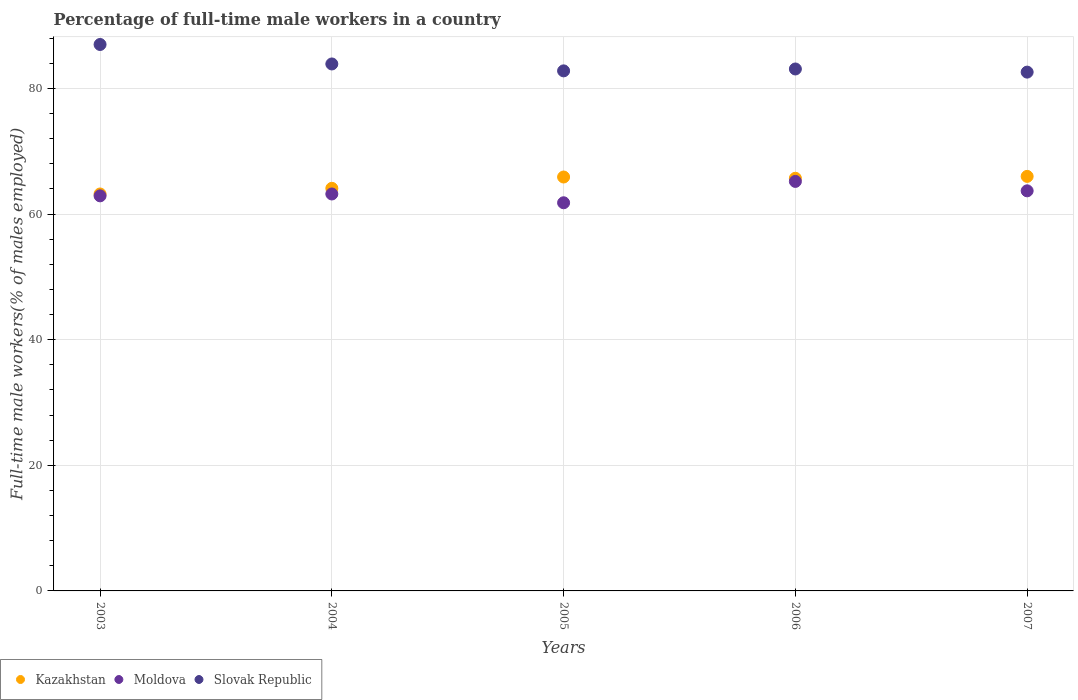How many different coloured dotlines are there?
Your response must be concise. 3. What is the percentage of full-time male workers in Slovak Republic in 2004?
Offer a very short reply. 83.9. Across all years, what is the maximum percentage of full-time male workers in Kazakhstan?
Offer a very short reply. 66. Across all years, what is the minimum percentage of full-time male workers in Moldova?
Ensure brevity in your answer.  61.8. What is the total percentage of full-time male workers in Moldova in the graph?
Keep it short and to the point. 316.8. What is the difference between the percentage of full-time male workers in Slovak Republic in 2004 and that in 2006?
Your answer should be very brief. 0.8. What is the difference between the percentage of full-time male workers in Slovak Republic in 2006 and the percentage of full-time male workers in Kazakhstan in 2003?
Keep it short and to the point. 19.9. What is the average percentage of full-time male workers in Kazakhstan per year?
Ensure brevity in your answer.  64.98. In the year 2003, what is the difference between the percentage of full-time male workers in Slovak Republic and percentage of full-time male workers in Kazakhstan?
Ensure brevity in your answer.  23.8. What is the ratio of the percentage of full-time male workers in Kazakhstan in 2004 to that in 2007?
Offer a terse response. 0.97. Is the percentage of full-time male workers in Moldova in 2003 less than that in 2006?
Make the answer very short. Yes. Is the difference between the percentage of full-time male workers in Slovak Republic in 2006 and 2007 greater than the difference between the percentage of full-time male workers in Kazakhstan in 2006 and 2007?
Make the answer very short. Yes. What is the difference between the highest and the second highest percentage of full-time male workers in Moldova?
Provide a short and direct response. 1.5. What is the difference between the highest and the lowest percentage of full-time male workers in Moldova?
Your response must be concise. 3.4. Is the sum of the percentage of full-time male workers in Kazakhstan in 2005 and 2007 greater than the maximum percentage of full-time male workers in Slovak Republic across all years?
Keep it short and to the point. Yes. Does the percentage of full-time male workers in Slovak Republic monotonically increase over the years?
Make the answer very short. No. Is the percentage of full-time male workers in Slovak Republic strictly greater than the percentage of full-time male workers in Kazakhstan over the years?
Provide a short and direct response. Yes. Is the percentage of full-time male workers in Moldova strictly less than the percentage of full-time male workers in Kazakhstan over the years?
Give a very brief answer. Yes. How many dotlines are there?
Make the answer very short. 3. How many years are there in the graph?
Make the answer very short. 5. Does the graph contain grids?
Provide a succinct answer. Yes. How many legend labels are there?
Offer a very short reply. 3. How are the legend labels stacked?
Provide a succinct answer. Horizontal. What is the title of the graph?
Ensure brevity in your answer.  Percentage of full-time male workers in a country. Does "Vanuatu" appear as one of the legend labels in the graph?
Offer a terse response. No. What is the label or title of the X-axis?
Provide a succinct answer. Years. What is the label or title of the Y-axis?
Make the answer very short. Full-time male workers(% of males employed). What is the Full-time male workers(% of males employed) of Kazakhstan in 2003?
Offer a terse response. 63.2. What is the Full-time male workers(% of males employed) in Moldova in 2003?
Offer a very short reply. 62.9. What is the Full-time male workers(% of males employed) of Kazakhstan in 2004?
Keep it short and to the point. 64.1. What is the Full-time male workers(% of males employed) of Moldova in 2004?
Your answer should be very brief. 63.2. What is the Full-time male workers(% of males employed) of Slovak Republic in 2004?
Ensure brevity in your answer.  83.9. What is the Full-time male workers(% of males employed) in Kazakhstan in 2005?
Keep it short and to the point. 65.9. What is the Full-time male workers(% of males employed) of Moldova in 2005?
Provide a short and direct response. 61.8. What is the Full-time male workers(% of males employed) in Slovak Republic in 2005?
Provide a short and direct response. 82.8. What is the Full-time male workers(% of males employed) of Kazakhstan in 2006?
Provide a short and direct response. 65.7. What is the Full-time male workers(% of males employed) of Moldova in 2006?
Give a very brief answer. 65.2. What is the Full-time male workers(% of males employed) of Slovak Republic in 2006?
Make the answer very short. 83.1. What is the Full-time male workers(% of males employed) of Kazakhstan in 2007?
Make the answer very short. 66. What is the Full-time male workers(% of males employed) of Moldova in 2007?
Make the answer very short. 63.7. What is the Full-time male workers(% of males employed) in Slovak Republic in 2007?
Offer a very short reply. 82.6. Across all years, what is the maximum Full-time male workers(% of males employed) of Moldova?
Ensure brevity in your answer.  65.2. Across all years, what is the maximum Full-time male workers(% of males employed) in Slovak Republic?
Offer a very short reply. 87. Across all years, what is the minimum Full-time male workers(% of males employed) of Kazakhstan?
Provide a succinct answer. 63.2. Across all years, what is the minimum Full-time male workers(% of males employed) in Moldova?
Your answer should be very brief. 61.8. Across all years, what is the minimum Full-time male workers(% of males employed) in Slovak Republic?
Ensure brevity in your answer.  82.6. What is the total Full-time male workers(% of males employed) of Kazakhstan in the graph?
Your answer should be compact. 324.9. What is the total Full-time male workers(% of males employed) in Moldova in the graph?
Ensure brevity in your answer.  316.8. What is the total Full-time male workers(% of males employed) in Slovak Republic in the graph?
Give a very brief answer. 419.4. What is the difference between the Full-time male workers(% of males employed) of Kazakhstan in 2003 and that in 2004?
Your answer should be very brief. -0.9. What is the difference between the Full-time male workers(% of males employed) of Moldova in 2003 and that in 2004?
Give a very brief answer. -0.3. What is the difference between the Full-time male workers(% of males employed) in Moldova in 2003 and that in 2005?
Provide a succinct answer. 1.1. What is the difference between the Full-time male workers(% of males employed) of Slovak Republic in 2003 and that in 2005?
Offer a very short reply. 4.2. What is the difference between the Full-time male workers(% of males employed) in Kazakhstan in 2003 and that in 2006?
Keep it short and to the point. -2.5. What is the difference between the Full-time male workers(% of males employed) in Slovak Republic in 2004 and that in 2005?
Provide a short and direct response. 1.1. What is the difference between the Full-time male workers(% of males employed) in Kazakhstan in 2004 and that in 2006?
Provide a short and direct response. -1.6. What is the difference between the Full-time male workers(% of males employed) of Slovak Republic in 2004 and that in 2006?
Offer a very short reply. 0.8. What is the difference between the Full-time male workers(% of males employed) of Kazakhstan in 2004 and that in 2007?
Make the answer very short. -1.9. What is the difference between the Full-time male workers(% of males employed) in Moldova in 2004 and that in 2007?
Keep it short and to the point. -0.5. What is the difference between the Full-time male workers(% of males employed) in Slovak Republic in 2004 and that in 2007?
Offer a terse response. 1.3. What is the difference between the Full-time male workers(% of males employed) in Kazakhstan in 2005 and that in 2006?
Your response must be concise. 0.2. What is the difference between the Full-time male workers(% of males employed) of Kazakhstan in 2005 and that in 2007?
Provide a succinct answer. -0.1. What is the difference between the Full-time male workers(% of males employed) of Slovak Republic in 2006 and that in 2007?
Make the answer very short. 0.5. What is the difference between the Full-time male workers(% of males employed) of Kazakhstan in 2003 and the Full-time male workers(% of males employed) of Slovak Republic in 2004?
Make the answer very short. -20.7. What is the difference between the Full-time male workers(% of males employed) in Kazakhstan in 2003 and the Full-time male workers(% of males employed) in Slovak Republic in 2005?
Offer a terse response. -19.6. What is the difference between the Full-time male workers(% of males employed) in Moldova in 2003 and the Full-time male workers(% of males employed) in Slovak Republic in 2005?
Your answer should be very brief. -19.9. What is the difference between the Full-time male workers(% of males employed) in Kazakhstan in 2003 and the Full-time male workers(% of males employed) in Moldova in 2006?
Your answer should be compact. -2. What is the difference between the Full-time male workers(% of males employed) of Kazakhstan in 2003 and the Full-time male workers(% of males employed) of Slovak Republic in 2006?
Provide a succinct answer. -19.9. What is the difference between the Full-time male workers(% of males employed) in Moldova in 2003 and the Full-time male workers(% of males employed) in Slovak Republic in 2006?
Keep it short and to the point. -20.2. What is the difference between the Full-time male workers(% of males employed) in Kazakhstan in 2003 and the Full-time male workers(% of males employed) in Slovak Republic in 2007?
Provide a succinct answer. -19.4. What is the difference between the Full-time male workers(% of males employed) of Moldova in 2003 and the Full-time male workers(% of males employed) of Slovak Republic in 2007?
Offer a very short reply. -19.7. What is the difference between the Full-time male workers(% of males employed) in Kazakhstan in 2004 and the Full-time male workers(% of males employed) in Slovak Republic in 2005?
Keep it short and to the point. -18.7. What is the difference between the Full-time male workers(% of males employed) in Moldova in 2004 and the Full-time male workers(% of males employed) in Slovak Republic in 2005?
Your answer should be compact. -19.6. What is the difference between the Full-time male workers(% of males employed) of Kazakhstan in 2004 and the Full-time male workers(% of males employed) of Moldova in 2006?
Provide a short and direct response. -1.1. What is the difference between the Full-time male workers(% of males employed) in Kazakhstan in 2004 and the Full-time male workers(% of males employed) in Slovak Republic in 2006?
Your response must be concise. -19. What is the difference between the Full-time male workers(% of males employed) in Moldova in 2004 and the Full-time male workers(% of males employed) in Slovak Republic in 2006?
Provide a short and direct response. -19.9. What is the difference between the Full-time male workers(% of males employed) in Kazakhstan in 2004 and the Full-time male workers(% of males employed) in Slovak Republic in 2007?
Give a very brief answer. -18.5. What is the difference between the Full-time male workers(% of males employed) of Moldova in 2004 and the Full-time male workers(% of males employed) of Slovak Republic in 2007?
Your response must be concise. -19.4. What is the difference between the Full-time male workers(% of males employed) of Kazakhstan in 2005 and the Full-time male workers(% of males employed) of Moldova in 2006?
Offer a very short reply. 0.7. What is the difference between the Full-time male workers(% of males employed) of Kazakhstan in 2005 and the Full-time male workers(% of males employed) of Slovak Republic in 2006?
Give a very brief answer. -17.2. What is the difference between the Full-time male workers(% of males employed) of Moldova in 2005 and the Full-time male workers(% of males employed) of Slovak Republic in 2006?
Offer a terse response. -21.3. What is the difference between the Full-time male workers(% of males employed) of Kazakhstan in 2005 and the Full-time male workers(% of males employed) of Slovak Republic in 2007?
Provide a short and direct response. -16.7. What is the difference between the Full-time male workers(% of males employed) in Moldova in 2005 and the Full-time male workers(% of males employed) in Slovak Republic in 2007?
Provide a succinct answer. -20.8. What is the difference between the Full-time male workers(% of males employed) in Kazakhstan in 2006 and the Full-time male workers(% of males employed) in Moldova in 2007?
Provide a succinct answer. 2. What is the difference between the Full-time male workers(% of males employed) in Kazakhstan in 2006 and the Full-time male workers(% of males employed) in Slovak Republic in 2007?
Your response must be concise. -16.9. What is the difference between the Full-time male workers(% of males employed) in Moldova in 2006 and the Full-time male workers(% of males employed) in Slovak Republic in 2007?
Provide a succinct answer. -17.4. What is the average Full-time male workers(% of males employed) in Kazakhstan per year?
Ensure brevity in your answer.  64.98. What is the average Full-time male workers(% of males employed) in Moldova per year?
Provide a short and direct response. 63.36. What is the average Full-time male workers(% of males employed) of Slovak Republic per year?
Keep it short and to the point. 83.88. In the year 2003, what is the difference between the Full-time male workers(% of males employed) in Kazakhstan and Full-time male workers(% of males employed) in Moldova?
Keep it short and to the point. 0.3. In the year 2003, what is the difference between the Full-time male workers(% of males employed) in Kazakhstan and Full-time male workers(% of males employed) in Slovak Republic?
Provide a succinct answer. -23.8. In the year 2003, what is the difference between the Full-time male workers(% of males employed) in Moldova and Full-time male workers(% of males employed) in Slovak Republic?
Your answer should be very brief. -24.1. In the year 2004, what is the difference between the Full-time male workers(% of males employed) of Kazakhstan and Full-time male workers(% of males employed) of Slovak Republic?
Provide a short and direct response. -19.8. In the year 2004, what is the difference between the Full-time male workers(% of males employed) in Moldova and Full-time male workers(% of males employed) in Slovak Republic?
Give a very brief answer. -20.7. In the year 2005, what is the difference between the Full-time male workers(% of males employed) in Kazakhstan and Full-time male workers(% of males employed) in Moldova?
Your answer should be very brief. 4.1. In the year 2005, what is the difference between the Full-time male workers(% of males employed) in Kazakhstan and Full-time male workers(% of males employed) in Slovak Republic?
Keep it short and to the point. -16.9. In the year 2005, what is the difference between the Full-time male workers(% of males employed) in Moldova and Full-time male workers(% of males employed) in Slovak Republic?
Your response must be concise. -21. In the year 2006, what is the difference between the Full-time male workers(% of males employed) in Kazakhstan and Full-time male workers(% of males employed) in Moldova?
Make the answer very short. 0.5. In the year 2006, what is the difference between the Full-time male workers(% of males employed) in Kazakhstan and Full-time male workers(% of males employed) in Slovak Republic?
Ensure brevity in your answer.  -17.4. In the year 2006, what is the difference between the Full-time male workers(% of males employed) of Moldova and Full-time male workers(% of males employed) of Slovak Republic?
Your answer should be very brief. -17.9. In the year 2007, what is the difference between the Full-time male workers(% of males employed) in Kazakhstan and Full-time male workers(% of males employed) in Slovak Republic?
Offer a very short reply. -16.6. In the year 2007, what is the difference between the Full-time male workers(% of males employed) in Moldova and Full-time male workers(% of males employed) in Slovak Republic?
Offer a very short reply. -18.9. What is the ratio of the Full-time male workers(% of males employed) in Kazakhstan in 2003 to that in 2004?
Offer a very short reply. 0.99. What is the ratio of the Full-time male workers(% of males employed) in Slovak Republic in 2003 to that in 2004?
Ensure brevity in your answer.  1.04. What is the ratio of the Full-time male workers(% of males employed) of Kazakhstan in 2003 to that in 2005?
Give a very brief answer. 0.96. What is the ratio of the Full-time male workers(% of males employed) in Moldova in 2003 to that in 2005?
Provide a succinct answer. 1.02. What is the ratio of the Full-time male workers(% of males employed) of Slovak Republic in 2003 to that in 2005?
Offer a terse response. 1.05. What is the ratio of the Full-time male workers(% of males employed) in Kazakhstan in 2003 to that in 2006?
Provide a succinct answer. 0.96. What is the ratio of the Full-time male workers(% of males employed) in Moldova in 2003 to that in 2006?
Ensure brevity in your answer.  0.96. What is the ratio of the Full-time male workers(% of males employed) of Slovak Republic in 2003 to that in 2006?
Keep it short and to the point. 1.05. What is the ratio of the Full-time male workers(% of males employed) in Kazakhstan in 2003 to that in 2007?
Keep it short and to the point. 0.96. What is the ratio of the Full-time male workers(% of males employed) in Moldova in 2003 to that in 2007?
Provide a short and direct response. 0.99. What is the ratio of the Full-time male workers(% of males employed) of Slovak Republic in 2003 to that in 2007?
Give a very brief answer. 1.05. What is the ratio of the Full-time male workers(% of males employed) of Kazakhstan in 2004 to that in 2005?
Give a very brief answer. 0.97. What is the ratio of the Full-time male workers(% of males employed) of Moldova in 2004 to that in 2005?
Provide a succinct answer. 1.02. What is the ratio of the Full-time male workers(% of males employed) in Slovak Republic in 2004 to that in 2005?
Provide a succinct answer. 1.01. What is the ratio of the Full-time male workers(% of males employed) of Kazakhstan in 2004 to that in 2006?
Give a very brief answer. 0.98. What is the ratio of the Full-time male workers(% of males employed) of Moldova in 2004 to that in 2006?
Provide a short and direct response. 0.97. What is the ratio of the Full-time male workers(% of males employed) of Slovak Republic in 2004 to that in 2006?
Your answer should be compact. 1.01. What is the ratio of the Full-time male workers(% of males employed) of Kazakhstan in 2004 to that in 2007?
Offer a very short reply. 0.97. What is the ratio of the Full-time male workers(% of males employed) of Slovak Republic in 2004 to that in 2007?
Your answer should be very brief. 1.02. What is the ratio of the Full-time male workers(% of males employed) in Kazakhstan in 2005 to that in 2006?
Provide a succinct answer. 1. What is the ratio of the Full-time male workers(% of males employed) in Moldova in 2005 to that in 2006?
Make the answer very short. 0.95. What is the ratio of the Full-time male workers(% of males employed) in Slovak Republic in 2005 to that in 2006?
Provide a succinct answer. 1. What is the ratio of the Full-time male workers(% of males employed) of Kazakhstan in 2005 to that in 2007?
Keep it short and to the point. 1. What is the ratio of the Full-time male workers(% of males employed) of Moldova in 2005 to that in 2007?
Keep it short and to the point. 0.97. What is the ratio of the Full-time male workers(% of males employed) in Kazakhstan in 2006 to that in 2007?
Provide a succinct answer. 1. What is the ratio of the Full-time male workers(% of males employed) of Moldova in 2006 to that in 2007?
Your answer should be compact. 1.02. What is the ratio of the Full-time male workers(% of males employed) of Slovak Republic in 2006 to that in 2007?
Your answer should be compact. 1.01. What is the difference between the highest and the second highest Full-time male workers(% of males employed) in Kazakhstan?
Give a very brief answer. 0.1. What is the difference between the highest and the lowest Full-time male workers(% of males employed) of Moldova?
Your answer should be compact. 3.4. What is the difference between the highest and the lowest Full-time male workers(% of males employed) of Slovak Republic?
Keep it short and to the point. 4.4. 